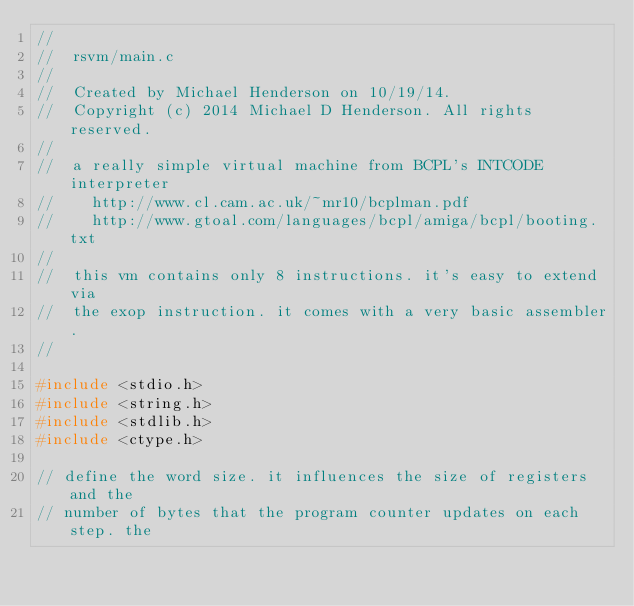Convert code to text. <code><loc_0><loc_0><loc_500><loc_500><_C_>//
//  rsvm/main.c
//
//  Created by Michael Henderson on 10/19/14.
//  Copyright (c) 2014 Michael D Henderson. All rights reserved.
//
//  a really simple virtual machine from BCPL's INTCODE interpreter
//    http://www.cl.cam.ac.uk/~mr10/bcplman.pdf
//    http://www.gtoal.com/languages/bcpl/amiga/bcpl/booting.txt
//
//  this vm contains only 8 instructions. it's easy to extend via
//  the exop instruction. it comes with a very basic assembler.
//

#include <stdio.h>
#include <string.h>
#include <stdlib.h>
#include <ctype.h>

// define the word size. it influences the size of registers and the
// number of bytes that the program counter updates on each step. the</code> 